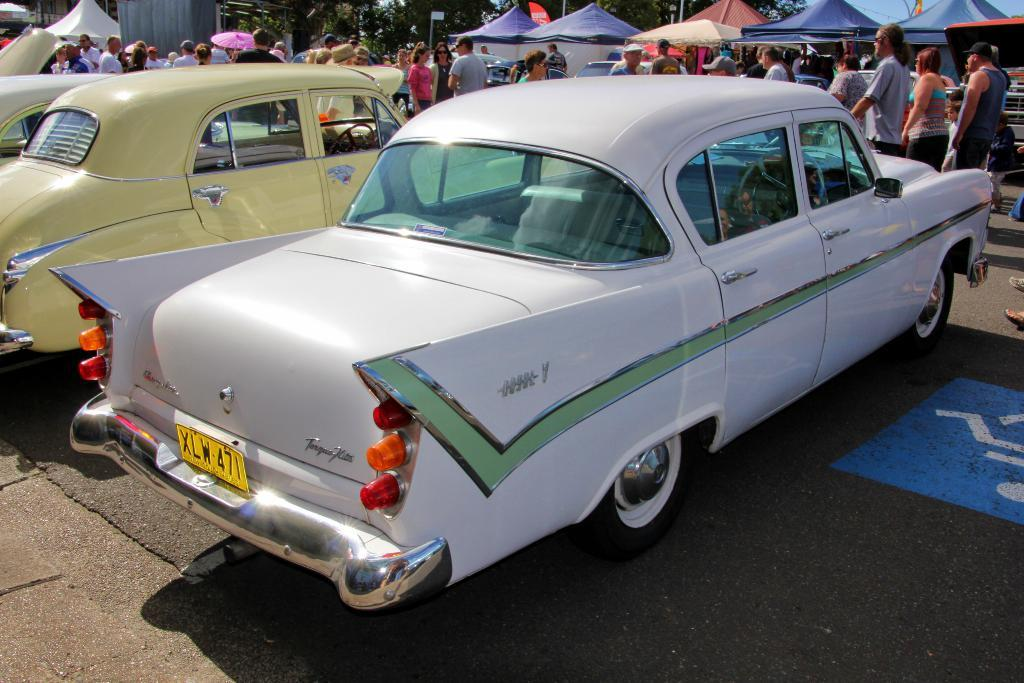What type of vehicles can be seen on the road in the image? There are cars on the road in the image. What else can be seen in the background of the image besides the road? There are people, tents, and trees visible in the background of the image. How many sheep are visible in the image? There are no sheep present in the image. What type of lipstick is the person wearing in the image? There is no indication of anyone wearing lipstick in the image. 